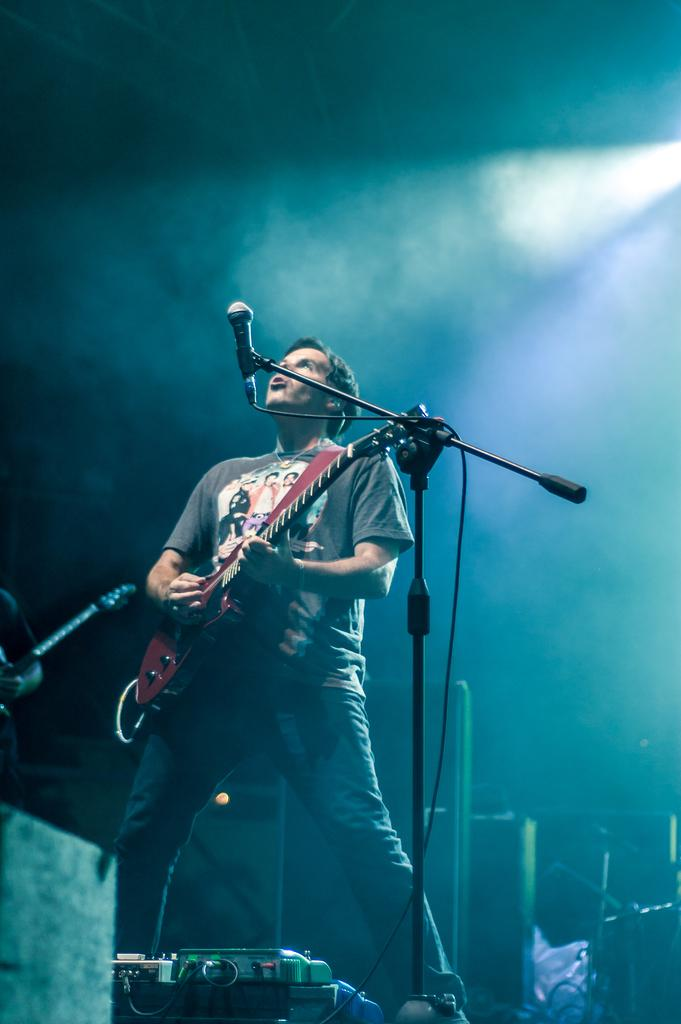What is the main subject of the image? The main subject of the image is a man. What is the man doing in the image? The man is standing and holding a guitar. What object is near the man in the image? The man is near a microphone. What can be seen in the background of the image? There are musical instruments and a light in the background of the image. What type of boot is the man wearing in the image? The image does not show the man wearing any boots; he is not wearing any footwear. What type of quartz can be seen in the image? There is no quartz present in the image. 